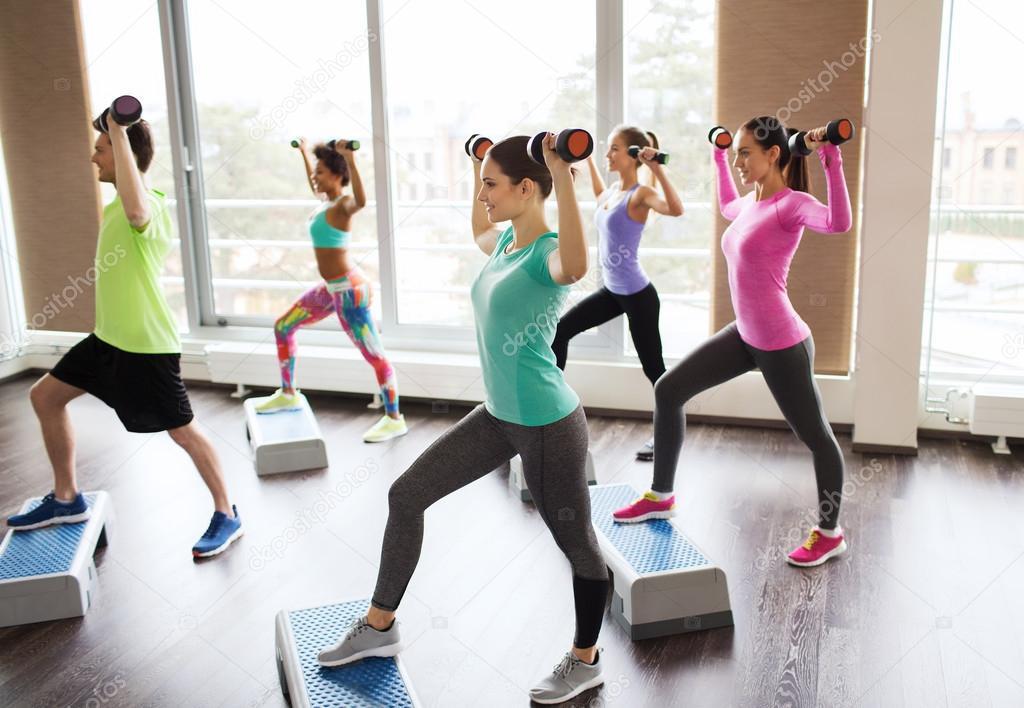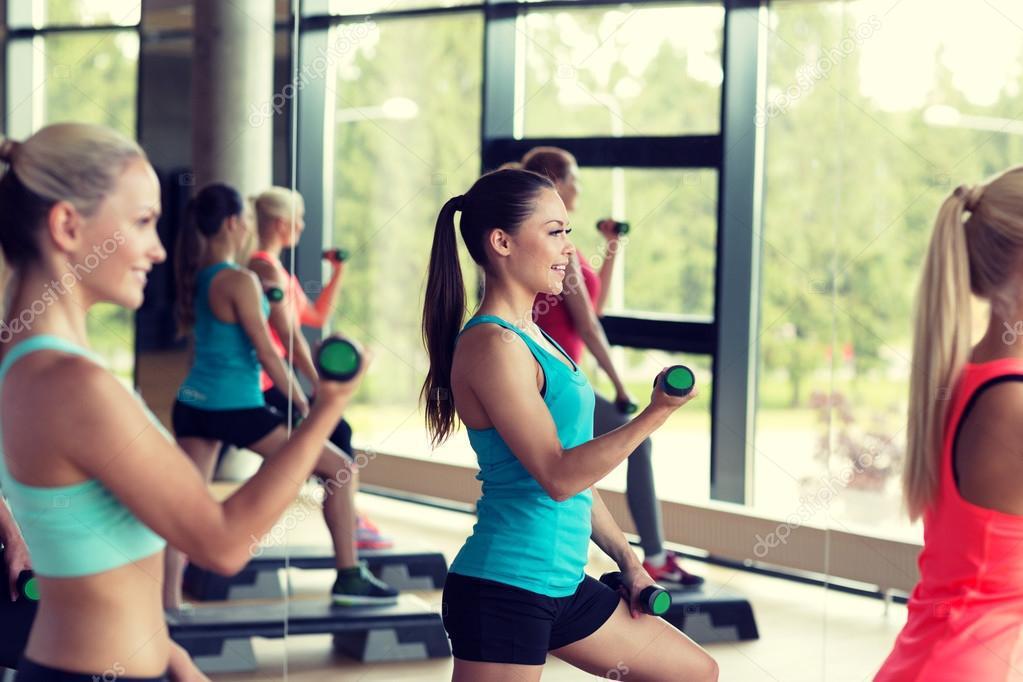The first image is the image on the left, the second image is the image on the right. Considering the images on both sides, is "There are nine people working out." valid? Answer yes or no. No. The first image is the image on the left, the second image is the image on the right. Assess this claim about the two images: "Nine or fewer humans are visible.". Correct or not? Answer yes or no. No. 